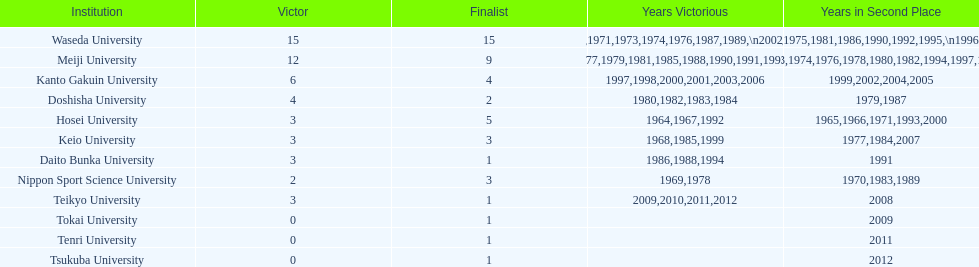Which universities had a number of wins higher than 12? Waseda University. 